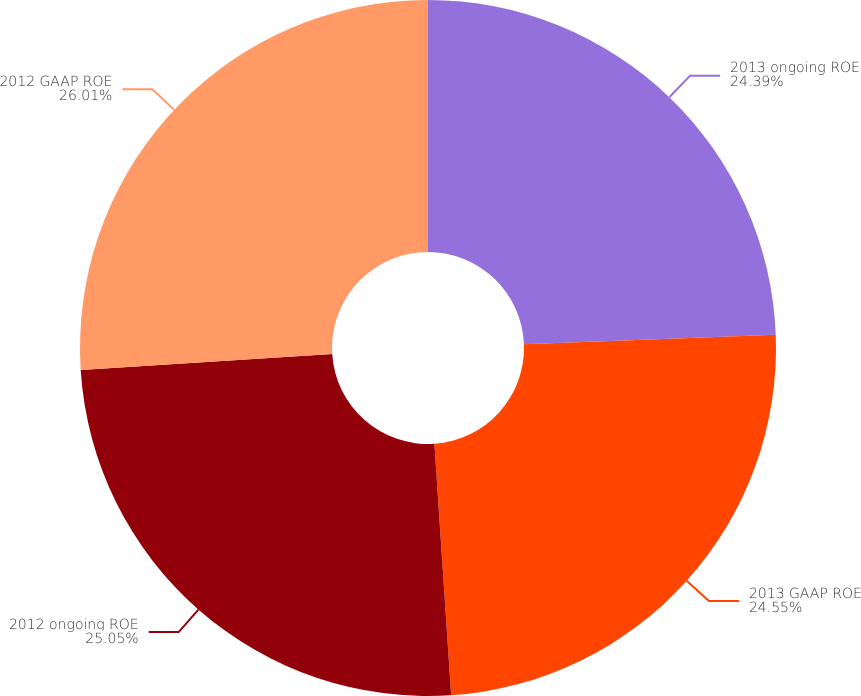Convert chart to OTSL. <chart><loc_0><loc_0><loc_500><loc_500><pie_chart><fcel>2013 ongoing ROE<fcel>2013 GAAP ROE<fcel>2012 ongoing ROE<fcel>2012 GAAP ROE<nl><fcel>24.39%<fcel>24.55%<fcel>25.05%<fcel>26.01%<nl></chart> 